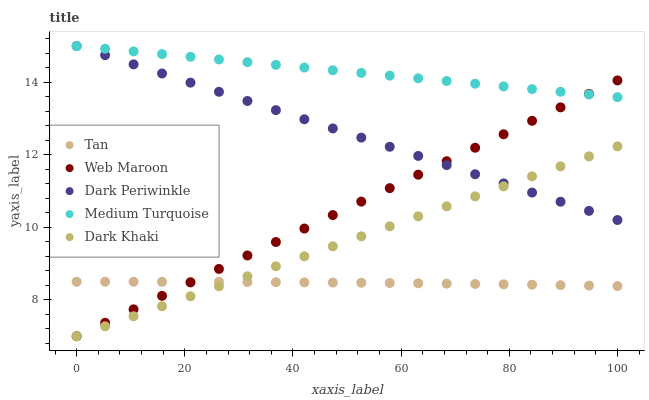Does Tan have the minimum area under the curve?
Answer yes or no. Yes. Does Medium Turquoise have the maximum area under the curve?
Answer yes or no. Yes. Does Web Maroon have the minimum area under the curve?
Answer yes or no. No. Does Web Maroon have the maximum area under the curve?
Answer yes or no. No. Is Web Maroon the smoothest?
Answer yes or no. Yes. Is Tan the roughest?
Answer yes or no. Yes. Is Tan the smoothest?
Answer yes or no. No. Is Web Maroon the roughest?
Answer yes or no. No. Does Dark Khaki have the lowest value?
Answer yes or no. Yes. Does Tan have the lowest value?
Answer yes or no. No. Does Medium Turquoise have the highest value?
Answer yes or no. Yes. Does Web Maroon have the highest value?
Answer yes or no. No. Is Tan less than Medium Turquoise?
Answer yes or no. Yes. Is Dark Periwinkle greater than Tan?
Answer yes or no. Yes. Does Tan intersect Dark Khaki?
Answer yes or no. Yes. Is Tan less than Dark Khaki?
Answer yes or no. No. Is Tan greater than Dark Khaki?
Answer yes or no. No. Does Tan intersect Medium Turquoise?
Answer yes or no. No. 